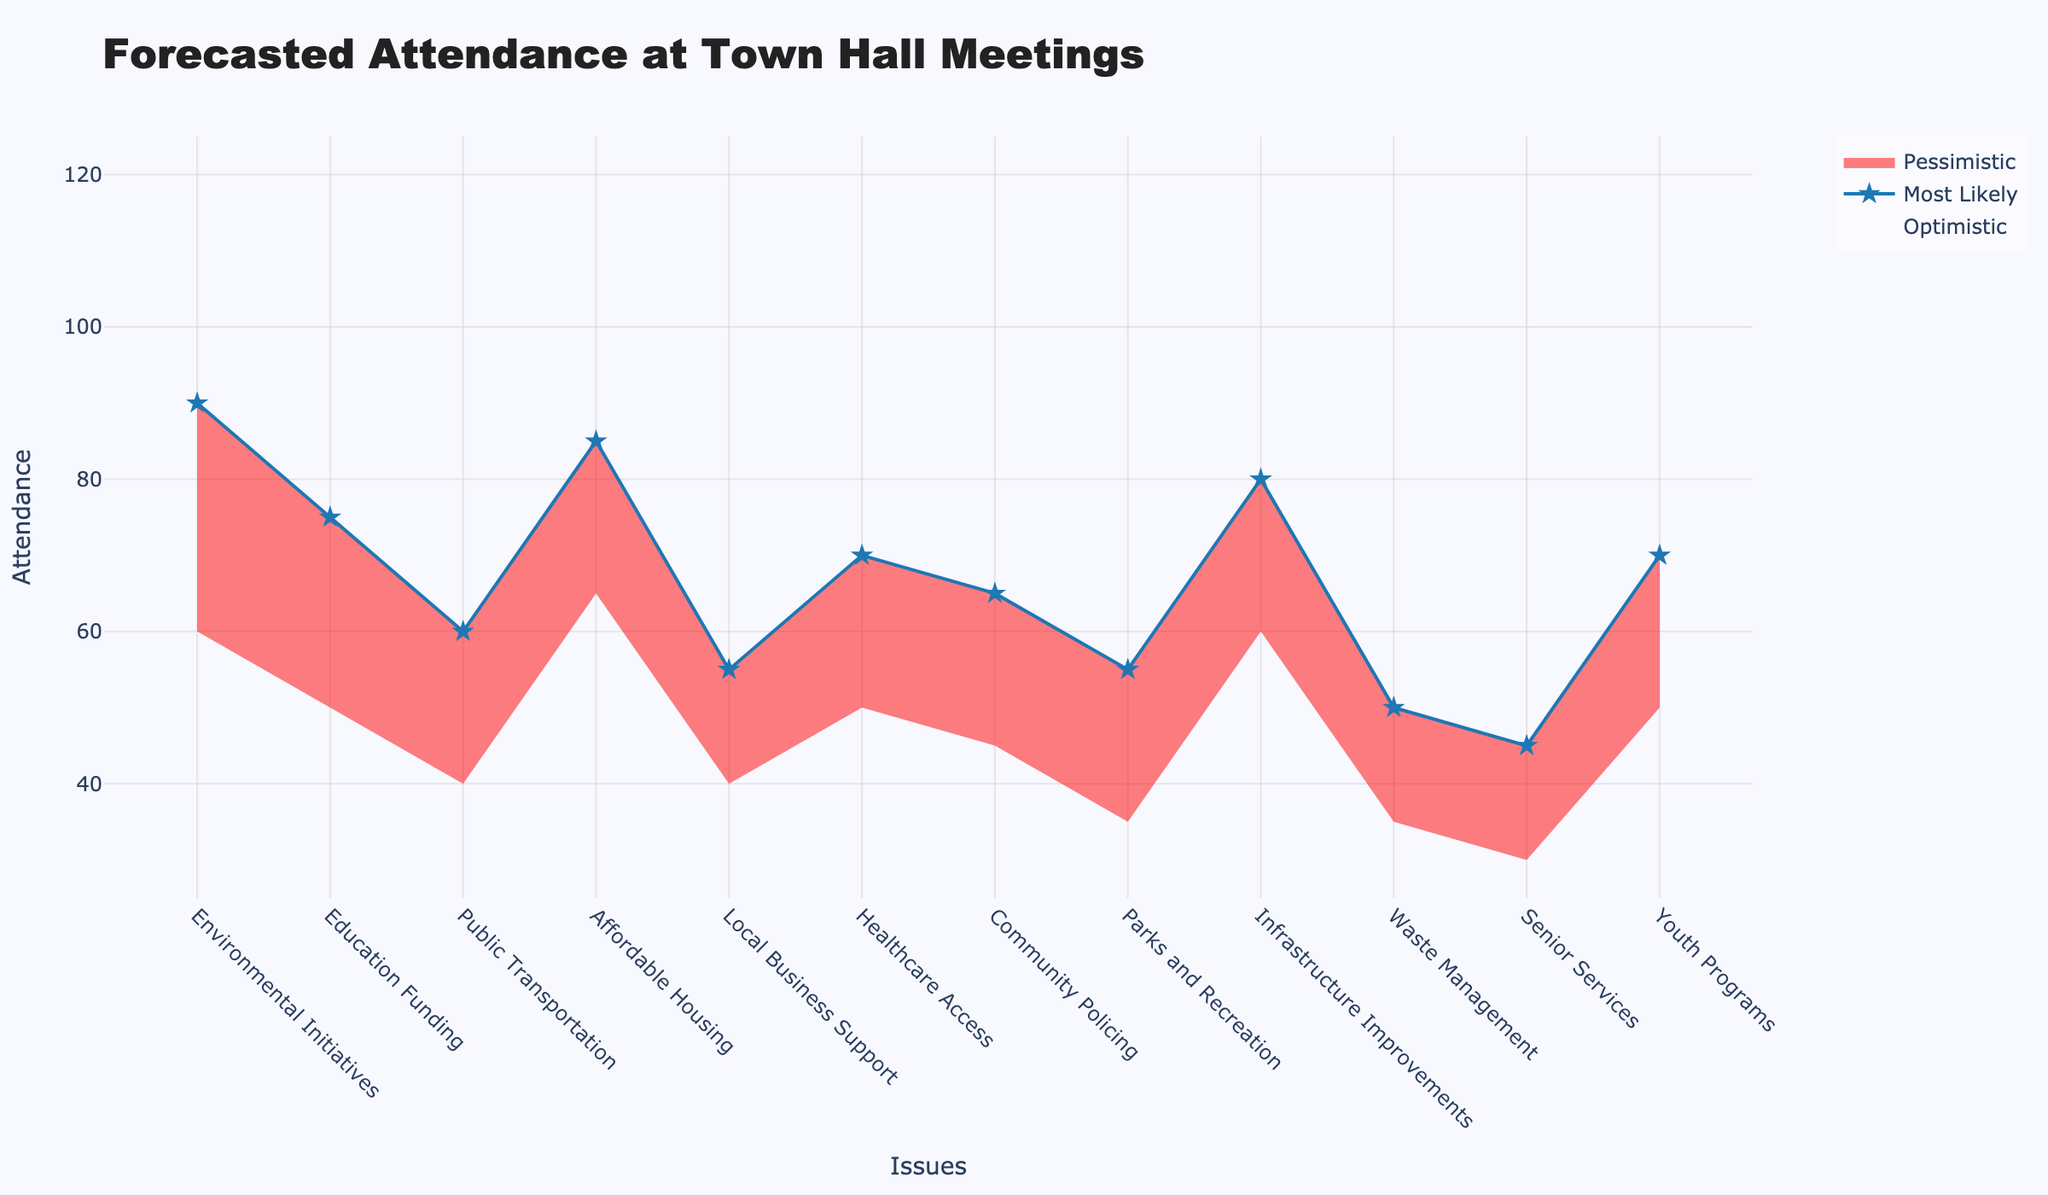What's the title of the figure? The title is usually found at the top of the figure. Here, it is presented in a larger and bold font which makes it easy to identify.
Answer: Forecasted Attendance at Town Hall Meetings What does the x-axis represent? The x-axis shows the categories that are being evaluated in the forecast. By looking at the labels on the x-axis, we can see that they are different issue topics.
Answer: Issues What is the range of the y-axis? The y-axis represents the attendance numbers and it's labeled accordingly. By observing the tick marks, we can determine the range of the y-axis values.
Answer: 0 to 150 Which issue has the highest most likely attendance? The "most likely" attendance numbers are marked by a line with star markers. We need to find the highest value among these markers and identify its corresponding issue.
Answer: Environmental Initiatives Which issue has the lowest pessimistic forecasted attendance? The pessimistic attendance numbers are represented by the bottom line filling in red. We need to find the lowest value among these lines and identify the corresponding issue.
Answer: Senior Services What is the difference between the optimistic and pessimistic attendance for Affordable Housing? Identify the optimistic and pessimistic values for Affordable Housing and subtract the pessimistic value from the optimistic value. The optimistic attendance is 110 and the pessimistic attendance is 65. Calculating the difference: 110 - 65 = 45
Answer: 45 What's the average most likely attendance across all issue topics? To calculate the average, sum all the "Most Likely" attendance numbers and divide by the total number of issues. The sum is 75+70+65+55+85+55+35+80+50+70 = 815 and there are 12 issue topics. Hence, 815 / 12 = 67.92
Answer: 67.92 How does the optimistic forecast for Healthcare Access compare to the pessimistic forecast for Local Business Support? Identify the optimistic forecast for Healthcare Access (95) and the pessimistic forecast for Local Business Support (40). Then compare these two values to see which one is greater.
Answer: Healthcare Access is greater Which issues have a forecasted most likely attendance between 60 and 80? Identify all issues whose most likely forecasted attendance values fall between 60 and 80 by looking at the middle value with star markers.
Answer: Public Transportation, Community Policing, Parks and Recreation, Waste Management, Youth Programs What is the range (difference between highest and lowest) of the most likely attendance among all issue topics? Find the highest and lowest most likely attendance values and calculate the difference. The highest is 90 for Environmental Initiatives and the lowest is 45 for Senior Services. The range is 90 - 45 = 45.
Answer: 45 